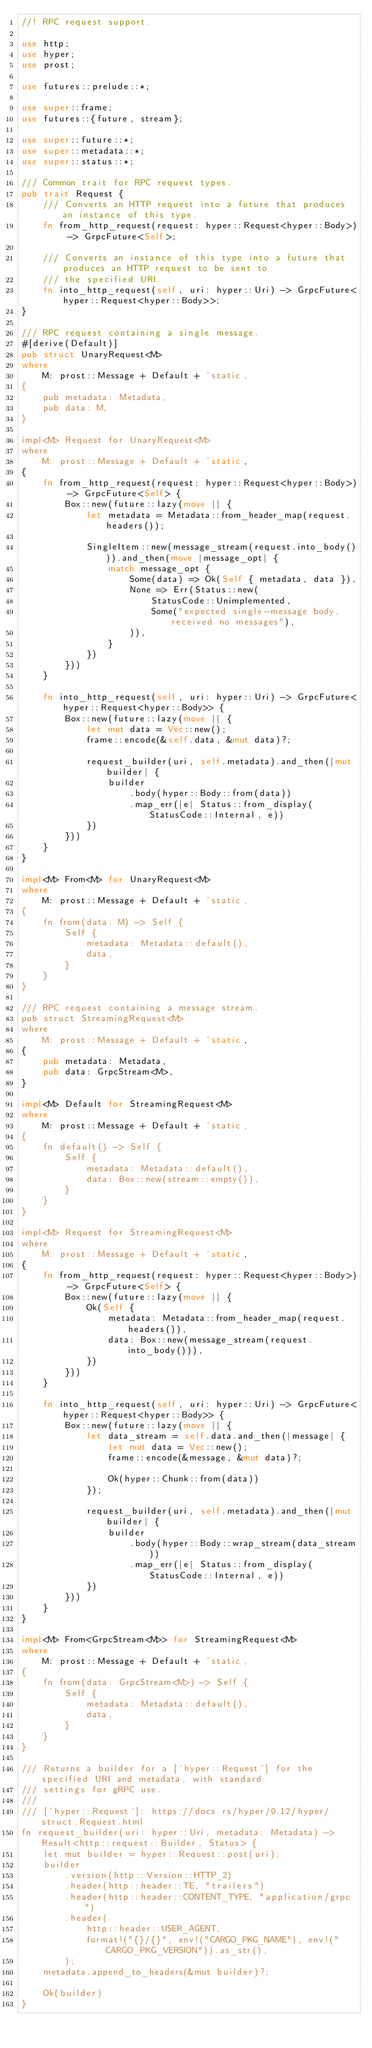Convert code to text. <code><loc_0><loc_0><loc_500><loc_500><_Rust_>//! RPC request support.

use http;
use hyper;
use prost;

use futures::prelude::*;

use super::frame;
use futures::{future, stream};

use super::future::*;
use super::metadata::*;
use super::status::*;

/// Common trait for RPC request types.
pub trait Request {
    /// Converts an HTTP request into a future that produces an instance of this type.
    fn from_http_request(request: hyper::Request<hyper::Body>) -> GrpcFuture<Self>;

    /// Converts an instance of this type into a future that produces an HTTP request to be sent to
    /// the specified URI.
    fn into_http_request(self, uri: hyper::Uri) -> GrpcFuture<hyper::Request<hyper::Body>>;
}

/// RPC request containing a single message.
#[derive(Default)]
pub struct UnaryRequest<M>
where
    M: prost::Message + Default + 'static,
{
    pub metadata: Metadata,
    pub data: M,
}

impl<M> Request for UnaryRequest<M>
where
    M: prost::Message + Default + 'static,
{
    fn from_http_request(request: hyper::Request<hyper::Body>) -> GrpcFuture<Self> {
        Box::new(future::lazy(move || {
            let metadata = Metadata::from_header_map(request.headers());

            SingleItem::new(message_stream(request.into_body())).and_then(move |message_opt| {
                match message_opt {
                    Some(data) => Ok(Self { metadata, data }),
                    None => Err(Status::new(
                        StatusCode::Unimplemented,
                        Some("expected single-message body, received no messages"),
                    )),
                }
            })
        }))
    }

    fn into_http_request(self, uri: hyper::Uri) -> GrpcFuture<hyper::Request<hyper::Body>> {
        Box::new(future::lazy(move || {
            let mut data = Vec::new();
            frame::encode(&self.data, &mut data)?;

            request_builder(uri, self.metadata).and_then(|mut builder| {
                builder
                    .body(hyper::Body::from(data))
                    .map_err(|e| Status::from_display(StatusCode::Internal, e))
            })
        }))
    }
}

impl<M> From<M> for UnaryRequest<M>
where
    M: prost::Message + Default + 'static,
{
    fn from(data: M) -> Self {
        Self {
            metadata: Metadata::default(),
            data,
        }
    }
}

/// RPC request containing a message stream.
pub struct StreamingRequest<M>
where
    M: prost::Message + Default + 'static,
{
    pub metadata: Metadata,
    pub data: GrpcStream<M>,
}

impl<M> Default for StreamingRequest<M>
where
    M: prost::Message + Default + 'static,
{
    fn default() -> Self {
        Self {
            metadata: Metadata::default(),
            data: Box::new(stream::empty()),
        }
    }
}

impl<M> Request for StreamingRequest<M>
where
    M: prost::Message + Default + 'static,
{
    fn from_http_request(request: hyper::Request<hyper::Body>) -> GrpcFuture<Self> {
        Box::new(future::lazy(move || {
            Ok(Self {
                metadata: Metadata::from_header_map(request.headers()),
                data: Box::new(message_stream(request.into_body())),
            })
        }))
    }

    fn into_http_request(self, uri: hyper::Uri) -> GrpcFuture<hyper::Request<hyper::Body>> {
        Box::new(future::lazy(move || {
            let data_stream = self.data.and_then(|message| {
                let mut data = Vec::new();
                frame::encode(&message, &mut data)?;

                Ok(hyper::Chunk::from(data))
            });

            request_builder(uri, self.metadata).and_then(|mut builder| {
                builder
                    .body(hyper::Body::wrap_stream(data_stream))
                    .map_err(|e| Status::from_display(StatusCode::Internal, e))
            })
        }))
    }
}

impl<M> From<GrpcStream<M>> for StreamingRequest<M>
where
    M: prost::Message + Default + 'static,
{
    fn from(data: GrpcStream<M>) -> Self {
        Self {
            metadata: Metadata::default(),
            data,
        }
    }
}

/// Returns a builder for a [`hyper::Request`] for the specified URI and metadata, with standard
/// settings for gRPC use.
///
/// [`hyper::Request`]: https://docs.rs/hyper/0.12/hyper/struct.Request.html
fn request_builder(uri: hyper::Uri, metadata: Metadata) -> Result<http::request::Builder, Status> {
    let mut builder = hyper::Request::post(uri);
    builder
        .version(http::Version::HTTP_2)
        .header(http::header::TE, "trailers")
        .header(http::header::CONTENT_TYPE, "application/grpc")
        .header(
            http::header::USER_AGENT,
            format!("{}/{}", env!("CARGO_PKG_NAME"), env!("CARGO_PKG_VERSION")).as_str(),
        );
    metadata.append_to_headers(&mut builder)?;

    Ok(builder)
}
</code> 